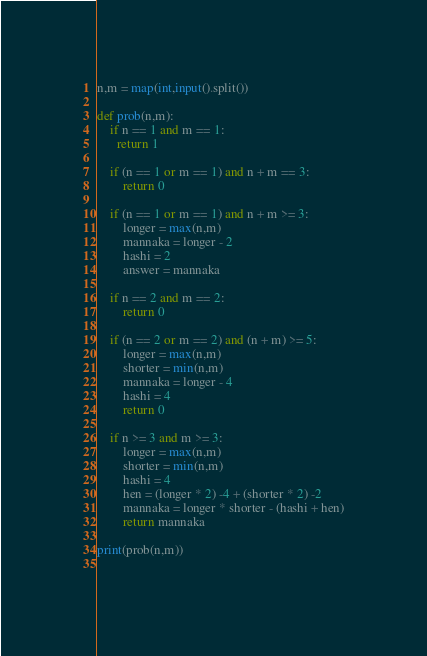Convert code to text. <code><loc_0><loc_0><loc_500><loc_500><_Python_>n,m = map(int,input().split())

def prob(n,m):
	if n == 1 and m == 1:
	  return 1
	
	if (n == 1 or m == 1) and n + m == 3:
  		return 0

	if (n == 1 or m == 1) and n + m >= 3:
  		longer = max(n,m)
  		mannaka = longer - 2
  		hashi = 2
  		answer = mannaka
  
	if n == 2 and m == 2:
  		return 0

	if (n == 2 or m == 2) and (n + m) >= 5:
  		longer = max(n,m)
  		shorter = min(n,m)
  		mannaka = longer - 4
  		hashi = 4
  		return 0

	if n >= 3 and m >= 3:
  		longer = max(n,m)
  		shorter = min(n,m)
  		hashi = 4
  		hen = (longer * 2) -4 + (shorter * 2) -2
        mannaka = longer * shorter - (hashi + hen)
        return mannaka
 
print(prob(n,m))
  </code> 